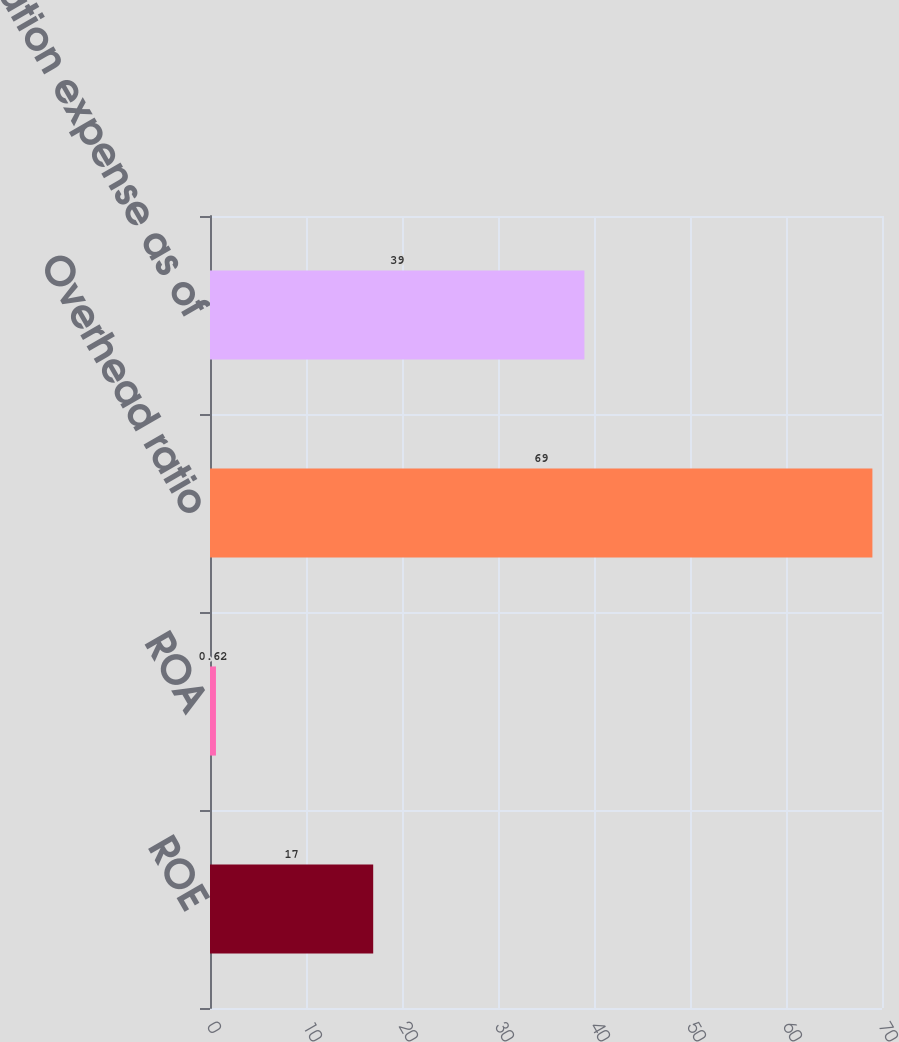Convert chart to OTSL. <chart><loc_0><loc_0><loc_500><loc_500><bar_chart><fcel>ROE<fcel>ROA<fcel>Overhead ratio<fcel>Compensation expense as of<nl><fcel>17<fcel>0.62<fcel>69<fcel>39<nl></chart> 